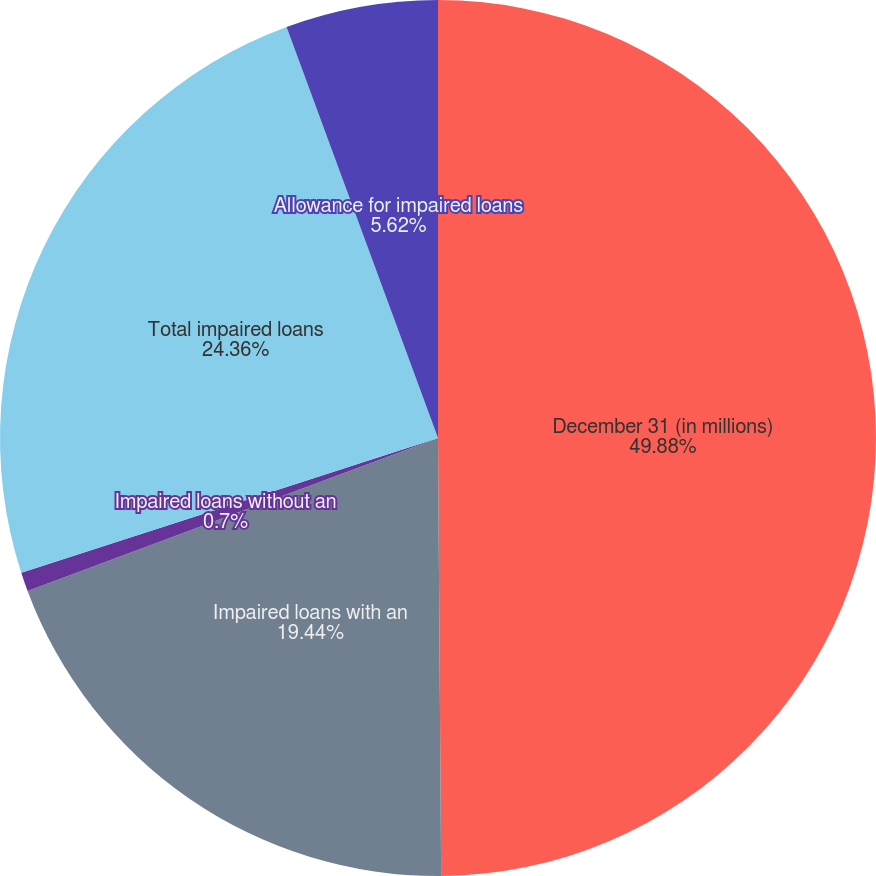<chart> <loc_0><loc_0><loc_500><loc_500><pie_chart><fcel>December 31 (in millions)<fcel>Impaired loans with an<fcel>Impaired loans without an<fcel>Total impaired loans<fcel>Allowance for impaired loans<nl><fcel>49.89%<fcel>19.44%<fcel>0.7%<fcel>24.36%<fcel>5.62%<nl></chart> 